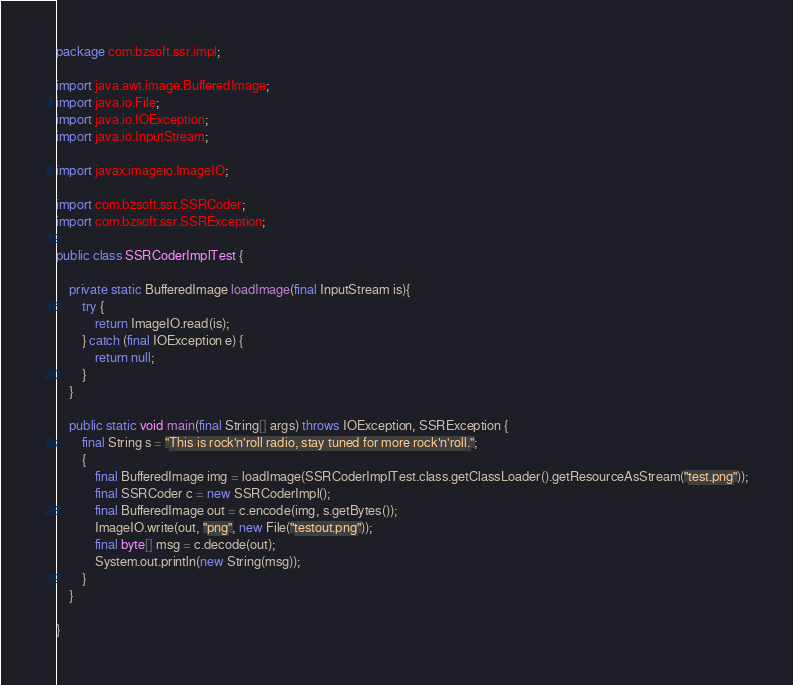<code> <loc_0><loc_0><loc_500><loc_500><_Java_>package com.bzsoft.ssr.impl;

import java.awt.image.BufferedImage;
import java.io.File;
import java.io.IOException;
import java.io.InputStream;

import javax.imageio.ImageIO;

import com.bzsoft.ssr.SSRCoder;
import com.bzsoft.ssr.SSRException;

public class SSRCoderImplTest {

	private static BufferedImage loadImage(final InputStream is){
		try {
			return ImageIO.read(is);
		} catch (final IOException e) {
			return null;
		}
	}

	public static void main(final String[] args) throws IOException, SSRException {
		final String s = "This is rock'n'roll radio, stay tuned for more rock'n'roll.";
		{
			final BufferedImage img = loadImage(SSRCoderImplTest.class.getClassLoader().getResourceAsStream("test.png"));
			final SSRCoder c = new SSRCoderImpl();
			final BufferedImage out = c.encode(img, s.getBytes());
			ImageIO.write(out, "png", new File("testout.png"));
			final byte[] msg = c.decode(out);
			System.out.println(new String(msg));
		}
	}

}
</code> 